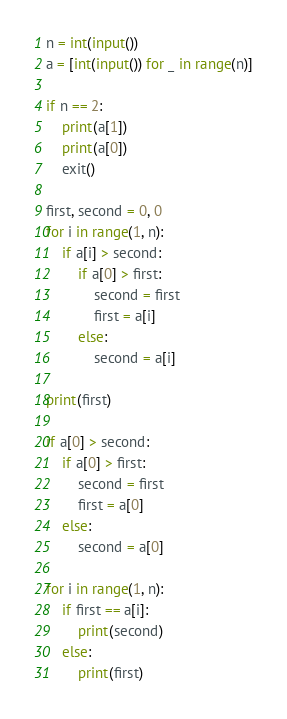Convert code to text. <code><loc_0><loc_0><loc_500><loc_500><_Python_>n = int(input())
a = [int(input()) for _ in range(n)]

if n == 2:
    print(a[1])
    print(a[0])
    exit()

first, second = 0, 0
for i in range(1, n):
    if a[i] > second:
        if a[0] > first:
            second = first
            first = a[i]
        else:
            second = a[i]

print(first)

if a[0] > second:
    if a[0] > first:
        second = first
        first = a[0]
    else:
        second = a[0]

for i in range(1, n):
    if first == a[i]:
        print(second)
    else:
        print(first)


</code> 